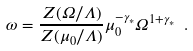Convert formula to latex. <formula><loc_0><loc_0><loc_500><loc_500>\omega = \frac { Z ( \Omega / \Lambda ) } { Z ( \mu _ { 0 } / \Lambda ) } \mu _ { 0 } ^ { - \gamma _ { * } } \Omega ^ { 1 + \gamma _ { * } } \ .</formula> 